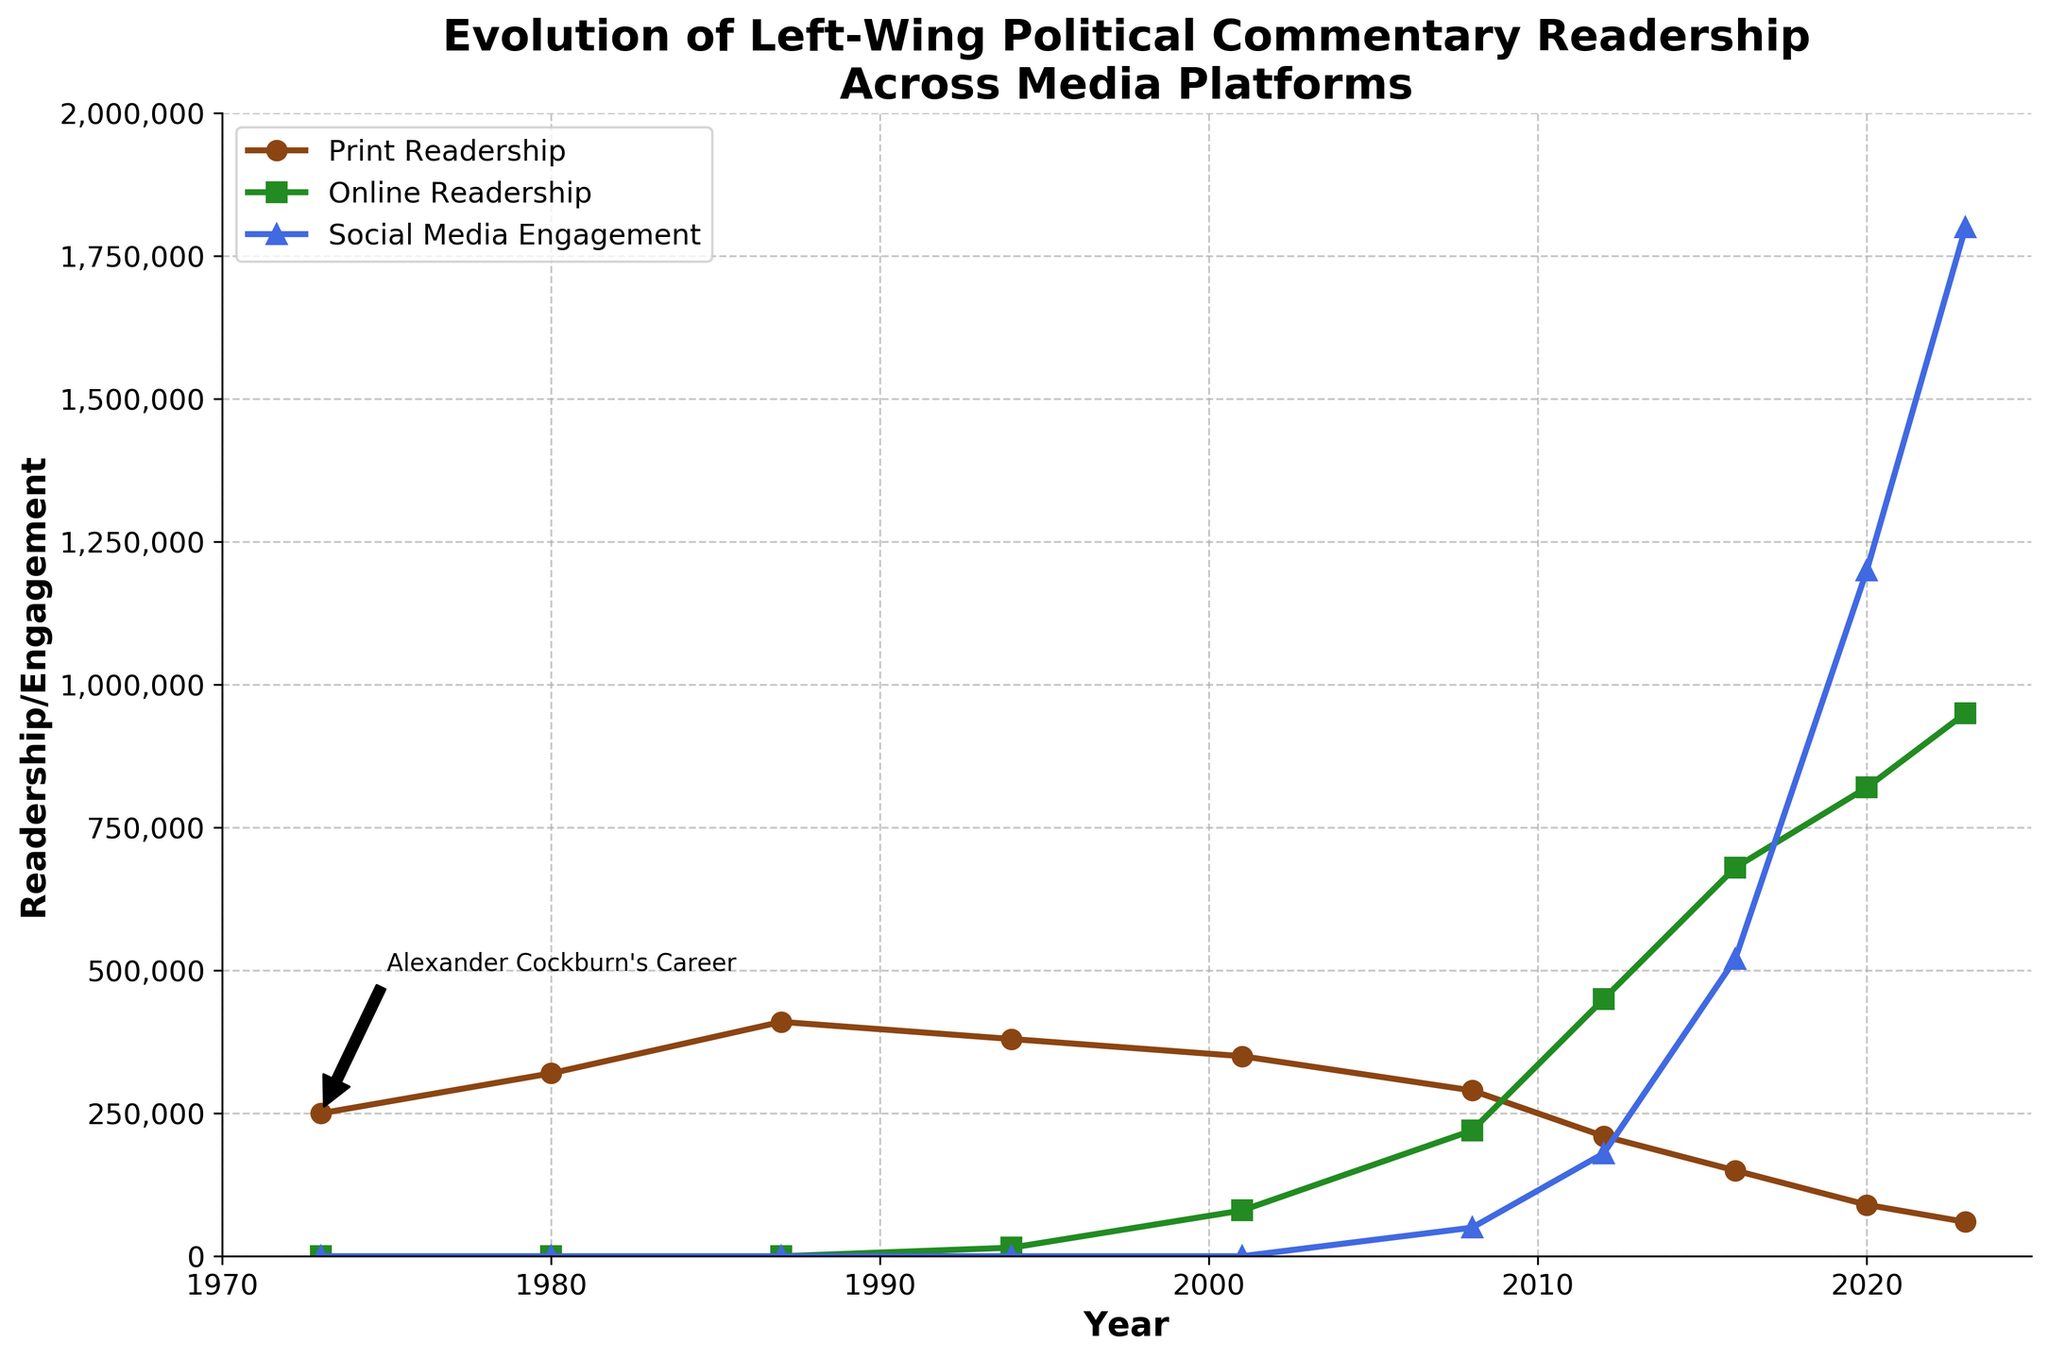what trend is observed in print readership over the years? Print readership started at 250,000 in 1973, peaked at 410,000 in 1987, and steadily declined to 60,000 by 2023. So the trend is an initial increase followed by a long-term decline.
Answer: Initial increase, then decline which year had the highest online readership, and what was the value? By looking at the plot, the year 2023 had the highest online readership, shown by the peak point for the green line representing online readership. The value was 950,000.
Answer: 2023, 950,000 how did social media engagement in 2023 compare to print readership in 1973? The plot shows that social media engagement in 2023 is represented by the blue line and print readership in 1973 by the brown line. Social media engagement in 2023 (1,800,000) is much higher than print readership in 1973 (250,000).
Answer: Higher in 2023 what is the combined readership/engagement for each platform in 2008? For 2008, print readership is 290,000, online readership is 220,000, and social media engagement is 50,000. Combined, this is 290,000 + 220,000 + 50,000 = 560,000.
Answer: 560,000 by how much did social media engagement increase from 2016 to 2020? From the plot, social media engagement in 2016 is 520,000 and in 2020 is 1,200,000. The increase is 1,200,000 - 520,000 = 680,000.
Answer: 680,000 compare the trends of print readership and online readership over the years Print readership (brown line) peaks in 1987 and then declines steadily. Online readership (green line) starts rising in 1994 and increases sharply, surpassing print readership around 2012 and continues to rise rapidly.
Answer: Print declines, online rises describe the visual difference between the line representing print readership and social media engagement The brown line for print readership starts high and declines, while the blue line for social media engagement starts at zero and rises sharply.
Answer: Print: down, Social Media: up how did online readership change between 1994 and 2001, and what is the overall trend? Online readership in 1994 was 15,000, and in 2001 it was 80,000. The change is 80,000 - 15,000 = 65,000, showing a rising trend during this period.
Answer: Increased by 65,000 what was the average online readership from 2008 to 2016? The values for online readership from 2008 to 2016 are 220,000, 450,000, and 680,000. The average is (220,000 + 450,000 + 680,000) / 3 = 1,350,000 / 3 = 450,000.
Answer: 450,000 between which years did print readership experience the steepest decline, and what is the drop in value? The plot shows the steepest decline in print readership between 2016 (150,000) and 2020 (90,000). The drop is 150,000 - 90,000 = 60,000.
Answer: Between 2016 and 2020, dropped by 60,000 